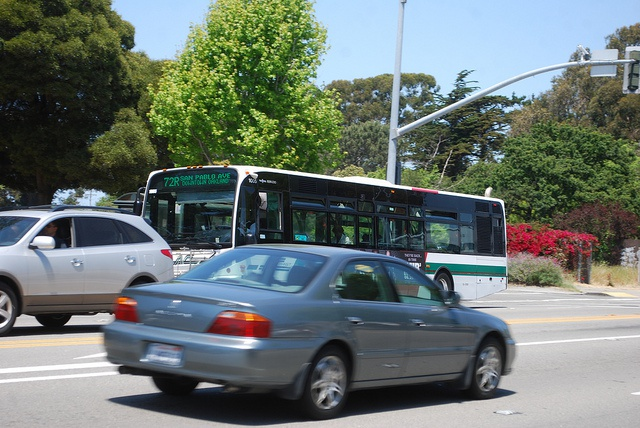Describe the objects in this image and their specific colors. I can see car in olive, gray, black, and blue tones, bus in olive, black, teal, lightgray, and navy tones, car in olive, darkgray, black, lavender, and gray tones, and traffic light in olive, gray, black, darkgray, and purple tones in this image. 